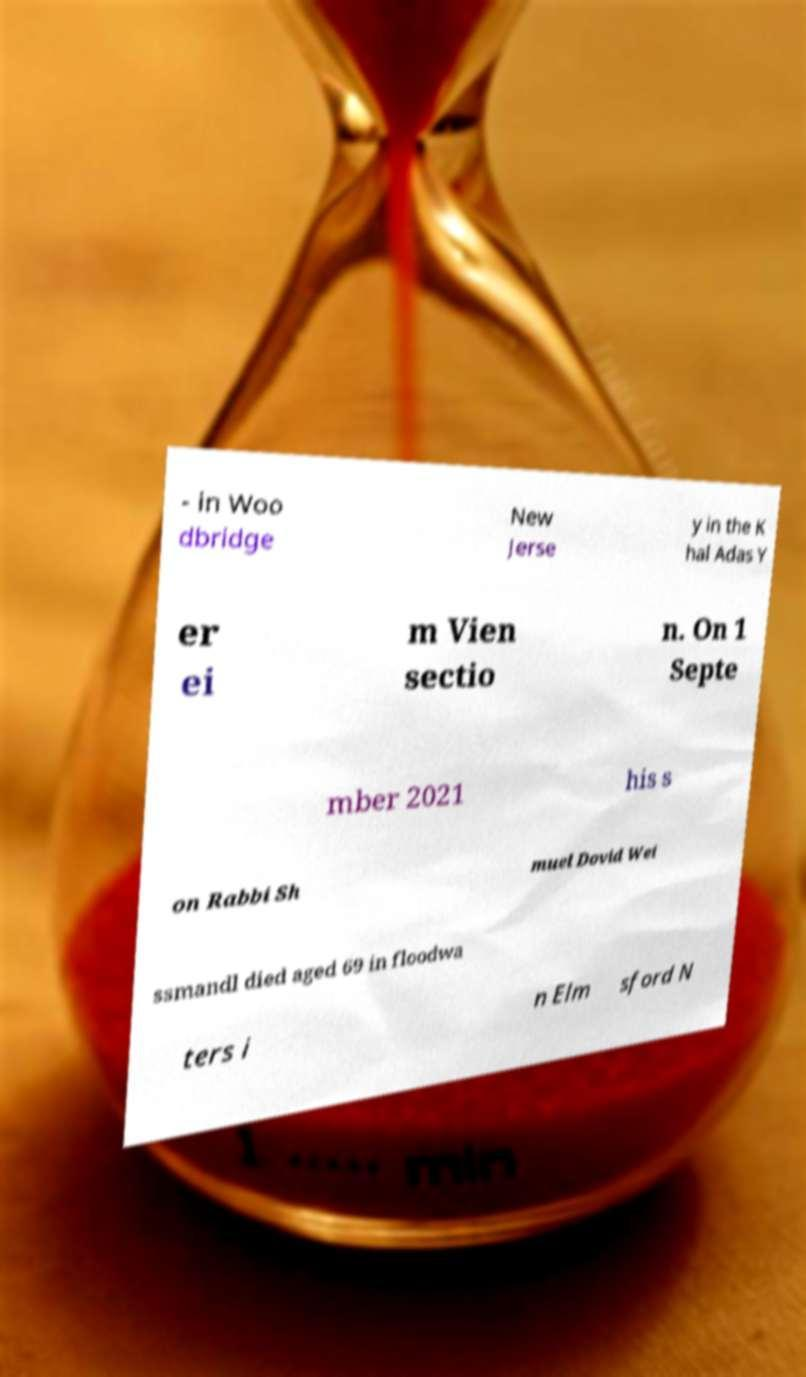Can you accurately transcribe the text from the provided image for me? - in Woo dbridge New Jerse y in the K hal Adas Y er ei m Vien sectio n. On 1 Septe mber 2021 his s on Rabbi Sh muel Dovid Wei ssmandl died aged 69 in floodwa ters i n Elm sford N 